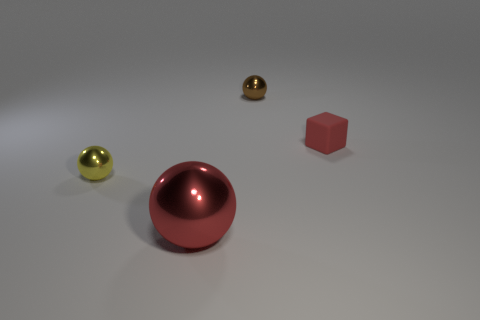Add 3 tiny brown things. How many objects exist? 7 Subtract all cubes. How many objects are left? 3 Add 1 brown objects. How many brown objects exist? 2 Subtract 0 brown cylinders. How many objects are left? 4 Subtract all tiny red matte things. Subtract all yellow shiny balls. How many objects are left? 2 Add 3 tiny rubber objects. How many tiny rubber objects are left? 4 